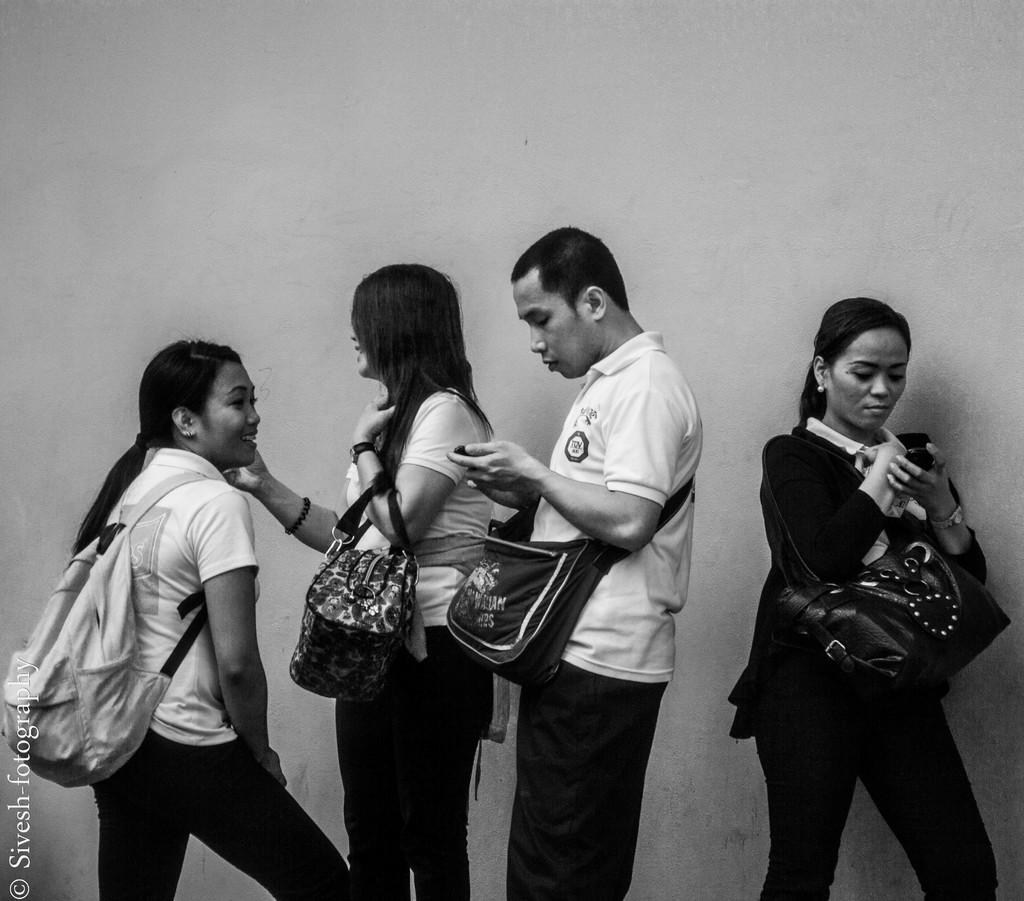How many people are present in the image? There are four people in the image. What are the people doing in the image? The people are standing in the image. What are the people holding in their hands? The people are holding bags in their hands, and two of them are also holding mobile phones. What type of cannon is being fired by the people in the image? There is no cannon present in the image; the people are holding bags and mobile phones. What type of cloth is being used by the people in the image? There is no cloth visible in the image; the people are holding bags and mobile phones. 